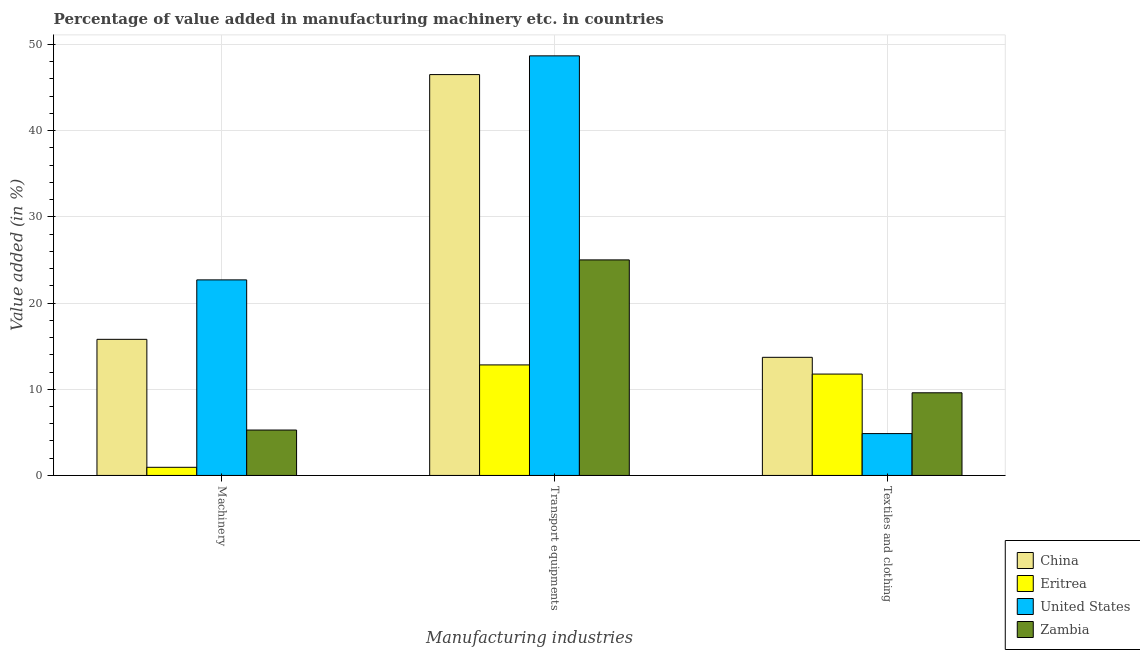How many different coloured bars are there?
Your answer should be compact. 4. How many groups of bars are there?
Offer a very short reply. 3. Are the number of bars on each tick of the X-axis equal?
Ensure brevity in your answer.  Yes. How many bars are there on the 3rd tick from the left?
Provide a short and direct response. 4. What is the label of the 3rd group of bars from the left?
Your answer should be compact. Textiles and clothing. What is the value added in manufacturing transport equipments in China?
Offer a terse response. 46.51. Across all countries, what is the maximum value added in manufacturing transport equipments?
Your answer should be compact. 48.68. Across all countries, what is the minimum value added in manufacturing transport equipments?
Provide a short and direct response. 12.82. In which country was the value added in manufacturing transport equipments maximum?
Your answer should be compact. United States. In which country was the value added in manufacturing machinery minimum?
Offer a terse response. Eritrea. What is the total value added in manufacturing textile and clothing in the graph?
Provide a short and direct response. 39.91. What is the difference between the value added in manufacturing machinery in United States and that in Zambia?
Offer a terse response. 17.42. What is the difference between the value added in manufacturing machinery in Zambia and the value added in manufacturing textile and clothing in Eritrea?
Make the answer very short. -6.49. What is the average value added in manufacturing transport equipments per country?
Keep it short and to the point. 33.25. What is the difference between the value added in manufacturing transport equipments and value added in manufacturing machinery in China?
Offer a terse response. 30.72. What is the ratio of the value added in manufacturing machinery in Zambia to that in Eritrea?
Give a very brief answer. 5.58. What is the difference between the highest and the second highest value added in manufacturing machinery?
Offer a terse response. 6.9. What is the difference between the highest and the lowest value added in manufacturing transport equipments?
Keep it short and to the point. 35.86. What does the 3rd bar from the left in Textiles and clothing represents?
Offer a terse response. United States. How many bars are there?
Provide a short and direct response. 12. What is the difference between two consecutive major ticks on the Y-axis?
Offer a terse response. 10. Does the graph contain any zero values?
Make the answer very short. No. Does the graph contain grids?
Your answer should be very brief. Yes. Where does the legend appear in the graph?
Ensure brevity in your answer.  Bottom right. How are the legend labels stacked?
Your answer should be compact. Vertical. What is the title of the graph?
Provide a short and direct response. Percentage of value added in manufacturing machinery etc. in countries. Does "High income: OECD" appear as one of the legend labels in the graph?
Offer a terse response. No. What is the label or title of the X-axis?
Your response must be concise. Manufacturing industries. What is the label or title of the Y-axis?
Your answer should be very brief. Value added (in %). What is the Value added (in %) in China in Machinery?
Provide a short and direct response. 15.79. What is the Value added (in %) of Eritrea in Machinery?
Your answer should be very brief. 0.94. What is the Value added (in %) of United States in Machinery?
Provide a succinct answer. 22.69. What is the Value added (in %) in Zambia in Machinery?
Give a very brief answer. 5.27. What is the Value added (in %) of China in Transport equipments?
Offer a terse response. 46.51. What is the Value added (in %) of Eritrea in Transport equipments?
Provide a succinct answer. 12.82. What is the Value added (in %) of United States in Transport equipments?
Ensure brevity in your answer.  48.68. What is the Value added (in %) of Zambia in Transport equipments?
Provide a succinct answer. 25.01. What is the Value added (in %) of China in Textiles and clothing?
Your answer should be very brief. 13.7. What is the Value added (in %) in Eritrea in Textiles and clothing?
Your response must be concise. 11.76. What is the Value added (in %) of United States in Textiles and clothing?
Your answer should be compact. 4.86. What is the Value added (in %) in Zambia in Textiles and clothing?
Your response must be concise. 9.59. Across all Manufacturing industries, what is the maximum Value added (in %) of China?
Provide a short and direct response. 46.51. Across all Manufacturing industries, what is the maximum Value added (in %) of Eritrea?
Your response must be concise. 12.82. Across all Manufacturing industries, what is the maximum Value added (in %) in United States?
Ensure brevity in your answer.  48.68. Across all Manufacturing industries, what is the maximum Value added (in %) of Zambia?
Your answer should be compact. 25.01. Across all Manufacturing industries, what is the minimum Value added (in %) in China?
Your answer should be compact. 13.7. Across all Manufacturing industries, what is the minimum Value added (in %) in Eritrea?
Provide a short and direct response. 0.94. Across all Manufacturing industries, what is the minimum Value added (in %) in United States?
Offer a very short reply. 4.86. Across all Manufacturing industries, what is the minimum Value added (in %) in Zambia?
Provide a short and direct response. 5.27. What is the total Value added (in %) of China in the graph?
Keep it short and to the point. 76. What is the total Value added (in %) in Eritrea in the graph?
Provide a short and direct response. 25.53. What is the total Value added (in %) of United States in the graph?
Provide a succinct answer. 76.22. What is the total Value added (in %) in Zambia in the graph?
Your answer should be very brief. 39.86. What is the difference between the Value added (in %) in China in Machinery and that in Transport equipments?
Provide a succinct answer. -30.72. What is the difference between the Value added (in %) of Eritrea in Machinery and that in Transport equipments?
Provide a succinct answer. -11.88. What is the difference between the Value added (in %) in United States in Machinery and that in Transport equipments?
Provide a short and direct response. -25.99. What is the difference between the Value added (in %) in Zambia in Machinery and that in Transport equipments?
Offer a terse response. -19.74. What is the difference between the Value added (in %) in China in Machinery and that in Textiles and clothing?
Offer a very short reply. 2.09. What is the difference between the Value added (in %) of Eritrea in Machinery and that in Textiles and clothing?
Give a very brief answer. -10.82. What is the difference between the Value added (in %) of United States in Machinery and that in Textiles and clothing?
Keep it short and to the point. 17.83. What is the difference between the Value added (in %) in Zambia in Machinery and that in Textiles and clothing?
Your answer should be very brief. -4.32. What is the difference between the Value added (in %) in China in Transport equipments and that in Textiles and clothing?
Your answer should be compact. 32.8. What is the difference between the Value added (in %) of Eritrea in Transport equipments and that in Textiles and clothing?
Offer a terse response. 1.06. What is the difference between the Value added (in %) in United States in Transport equipments and that in Textiles and clothing?
Give a very brief answer. 43.82. What is the difference between the Value added (in %) in Zambia in Transport equipments and that in Textiles and clothing?
Your answer should be compact. 15.42. What is the difference between the Value added (in %) in China in Machinery and the Value added (in %) in Eritrea in Transport equipments?
Offer a very short reply. 2.97. What is the difference between the Value added (in %) in China in Machinery and the Value added (in %) in United States in Transport equipments?
Your response must be concise. -32.89. What is the difference between the Value added (in %) of China in Machinery and the Value added (in %) of Zambia in Transport equipments?
Make the answer very short. -9.22. What is the difference between the Value added (in %) in Eritrea in Machinery and the Value added (in %) in United States in Transport equipments?
Your answer should be compact. -47.73. What is the difference between the Value added (in %) of Eritrea in Machinery and the Value added (in %) of Zambia in Transport equipments?
Your response must be concise. -24.06. What is the difference between the Value added (in %) in United States in Machinery and the Value added (in %) in Zambia in Transport equipments?
Offer a terse response. -2.32. What is the difference between the Value added (in %) of China in Machinery and the Value added (in %) of Eritrea in Textiles and clothing?
Offer a terse response. 4.03. What is the difference between the Value added (in %) in China in Machinery and the Value added (in %) in United States in Textiles and clothing?
Give a very brief answer. 10.93. What is the difference between the Value added (in %) in China in Machinery and the Value added (in %) in Zambia in Textiles and clothing?
Your response must be concise. 6.2. What is the difference between the Value added (in %) in Eritrea in Machinery and the Value added (in %) in United States in Textiles and clothing?
Make the answer very short. -3.91. What is the difference between the Value added (in %) of Eritrea in Machinery and the Value added (in %) of Zambia in Textiles and clothing?
Offer a terse response. -8.64. What is the difference between the Value added (in %) of United States in Machinery and the Value added (in %) of Zambia in Textiles and clothing?
Offer a very short reply. 13.1. What is the difference between the Value added (in %) in China in Transport equipments and the Value added (in %) in Eritrea in Textiles and clothing?
Make the answer very short. 34.74. What is the difference between the Value added (in %) of China in Transport equipments and the Value added (in %) of United States in Textiles and clothing?
Ensure brevity in your answer.  41.65. What is the difference between the Value added (in %) of China in Transport equipments and the Value added (in %) of Zambia in Textiles and clothing?
Your response must be concise. 36.92. What is the difference between the Value added (in %) in Eritrea in Transport equipments and the Value added (in %) in United States in Textiles and clothing?
Your answer should be compact. 7.97. What is the difference between the Value added (in %) in Eritrea in Transport equipments and the Value added (in %) in Zambia in Textiles and clothing?
Give a very brief answer. 3.23. What is the difference between the Value added (in %) of United States in Transport equipments and the Value added (in %) of Zambia in Textiles and clothing?
Give a very brief answer. 39.09. What is the average Value added (in %) in China per Manufacturing industries?
Provide a short and direct response. 25.33. What is the average Value added (in %) of Eritrea per Manufacturing industries?
Your response must be concise. 8.51. What is the average Value added (in %) in United States per Manufacturing industries?
Provide a succinct answer. 25.41. What is the average Value added (in %) of Zambia per Manufacturing industries?
Offer a very short reply. 13.29. What is the difference between the Value added (in %) of China and Value added (in %) of Eritrea in Machinery?
Offer a very short reply. 14.85. What is the difference between the Value added (in %) in China and Value added (in %) in United States in Machinery?
Offer a terse response. -6.9. What is the difference between the Value added (in %) of China and Value added (in %) of Zambia in Machinery?
Offer a very short reply. 10.52. What is the difference between the Value added (in %) in Eritrea and Value added (in %) in United States in Machinery?
Make the answer very short. -21.74. What is the difference between the Value added (in %) in Eritrea and Value added (in %) in Zambia in Machinery?
Offer a very short reply. -4.32. What is the difference between the Value added (in %) of United States and Value added (in %) of Zambia in Machinery?
Give a very brief answer. 17.42. What is the difference between the Value added (in %) in China and Value added (in %) in Eritrea in Transport equipments?
Keep it short and to the point. 33.68. What is the difference between the Value added (in %) of China and Value added (in %) of United States in Transport equipments?
Provide a succinct answer. -2.17. What is the difference between the Value added (in %) of China and Value added (in %) of Zambia in Transport equipments?
Keep it short and to the point. 21.5. What is the difference between the Value added (in %) of Eritrea and Value added (in %) of United States in Transport equipments?
Your answer should be very brief. -35.86. What is the difference between the Value added (in %) of Eritrea and Value added (in %) of Zambia in Transport equipments?
Ensure brevity in your answer.  -12.18. What is the difference between the Value added (in %) of United States and Value added (in %) of Zambia in Transport equipments?
Give a very brief answer. 23.67. What is the difference between the Value added (in %) of China and Value added (in %) of Eritrea in Textiles and clothing?
Your answer should be very brief. 1.94. What is the difference between the Value added (in %) in China and Value added (in %) in United States in Textiles and clothing?
Provide a succinct answer. 8.85. What is the difference between the Value added (in %) in China and Value added (in %) in Zambia in Textiles and clothing?
Keep it short and to the point. 4.11. What is the difference between the Value added (in %) in Eritrea and Value added (in %) in United States in Textiles and clothing?
Offer a very short reply. 6.91. What is the difference between the Value added (in %) in Eritrea and Value added (in %) in Zambia in Textiles and clothing?
Offer a terse response. 2.17. What is the difference between the Value added (in %) in United States and Value added (in %) in Zambia in Textiles and clothing?
Make the answer very short. -4.73. What is the ratio of the Value added (in %) of China in Machinery to that in Transport equipments?
Your response must be concise. 0.34. What is the ratio of the Value added (in %) of Eritrea in Machinery to that in Transport equipments?
Your response must be concise. 0.07. What is the ratio of the Value added (in %) of United States in Machinery to that in Transport equipments?
Provide a succinct answer. 0.47. What is the ratio of the Value added (in %) in Zambia in Machinery to that in Transport equipments?
Make the answer very short. 0.21. What is the ratio of the Value added (in %) of China in Machinery to that in Textiles and clothing?
Your response must be concise. 1.15. What is the ratio of the Value added (in %) in Eritrea in Machinery to that in Textiles and clothing?
Offer a terse response. 0.08. What is the ratio of the Value added (in %) of United States in Machinery to that in Textiles and clothing?
Ensure brevity in your answer.  4.67. What is the ratio of the Value added (in %) in Zambia in Machinery to that in Textiles and clothing?
Ensure brevity in your answer.  0.55. What is the ratio of the Value added (in %) of China in Transport equipments to that in Textiles and clothing?
Provide a succinct answer. 3.39. What is the ratio of the Value added (in %) of Eritrea in Transport equipments to that in Textiles and clothing?
Give a very brief answer. 1.09. What is the ratio of the Value added (in %) of United States in Transport equipments to that in Textiles and clothing?
Offer a very short reply. 10.03. What is the ratio of the Value added (in %) in Zambia in Transport equipments to that in Textiles and clothing?
Your answer should be very brief. 2.61. What is the difference between the highest and the second highest Value added (in %) of China?
Your answer should be very brief. 30.72. What is the difference between the highest and the second highest Value added (in %) of Eritrea?
Ensure brevity in your answer.  1.06. What is the difference between the highest and the second highest Value added (in %) of United States?
Make the answer very short. 25.99. What is the difference between the highest and the second highest Value added (in %) in Zambia?
Your answer should be compact. 15.42. What is the difference between the highest and the lowest Value added (in %) in China?
Ensure brevity in your answer.  32.8. What is the difference between the highest and the lowest Value added (in %) of Eritrea?
Provide a short and direct response. 11.88. What is the difference between the highest and the lowest Value added (in %) of United States?
Offer a terse response. 43.82. What is the difference between the highest and the lowest Value added (in %) in Zambia?
Your answer should be very brief. 19.74. 